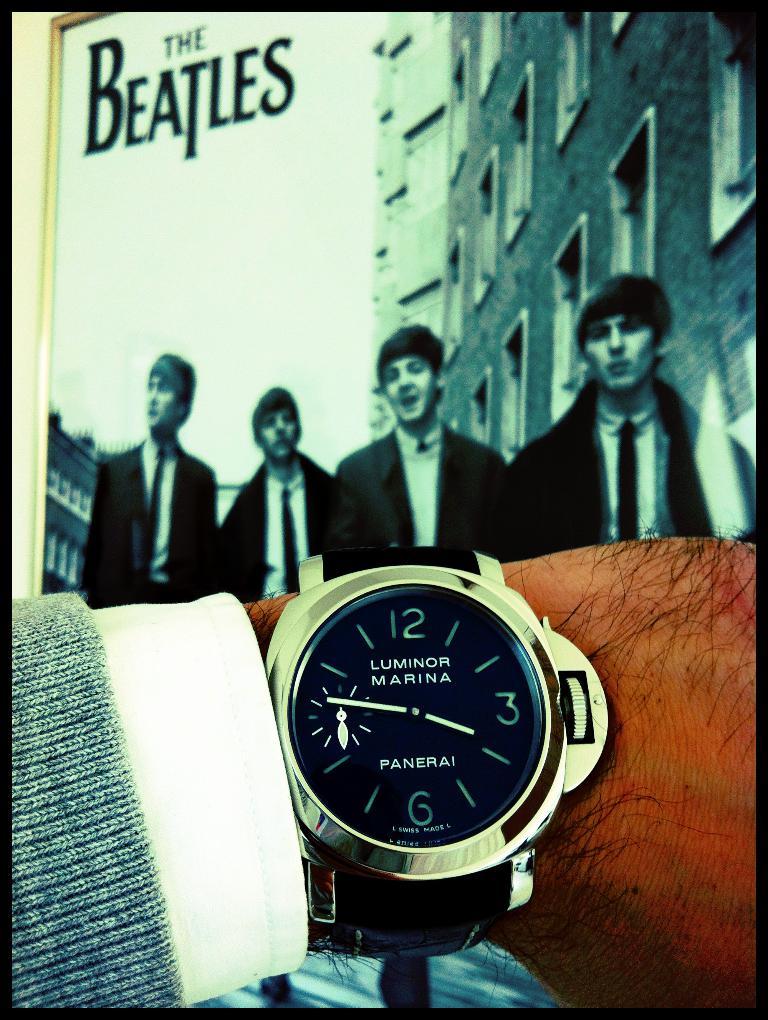What is the watch called?
Keep it short and to the point. Luminor marina. What is the band shown in the back on the giant poster?
Ensure brevity in your answer.  The beatles. 